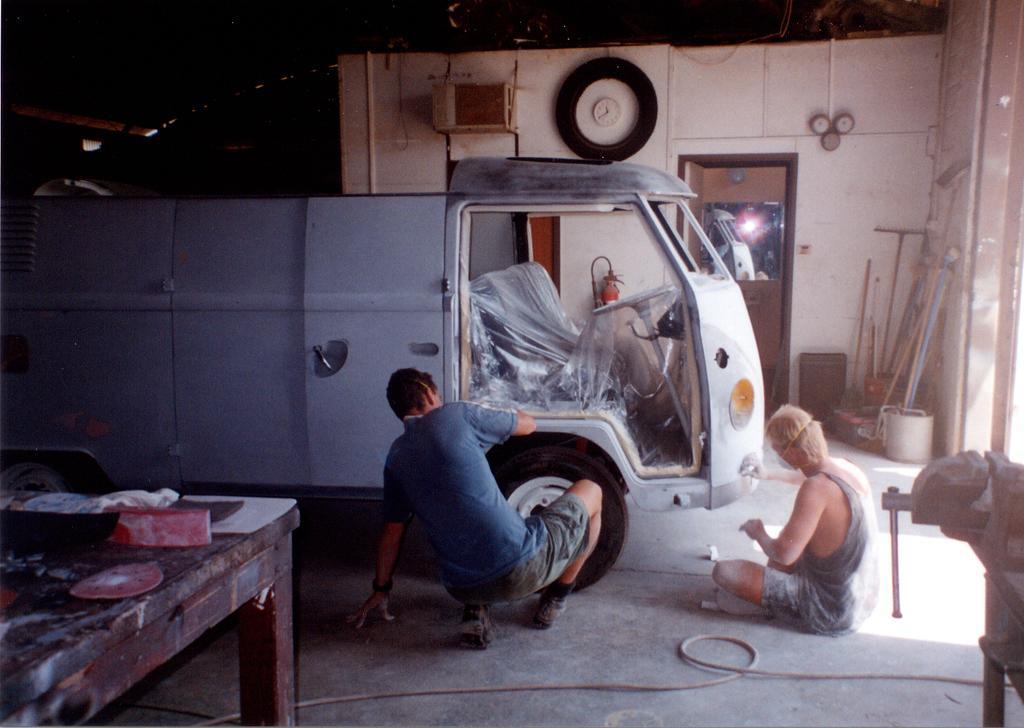Please provide a concise description of this image. This picture shows two people painting a truck 